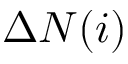Convert formula to latex. <formula><loc_0><loc_0><loc_500><loc_500>\Delta N ( i )</formula> 